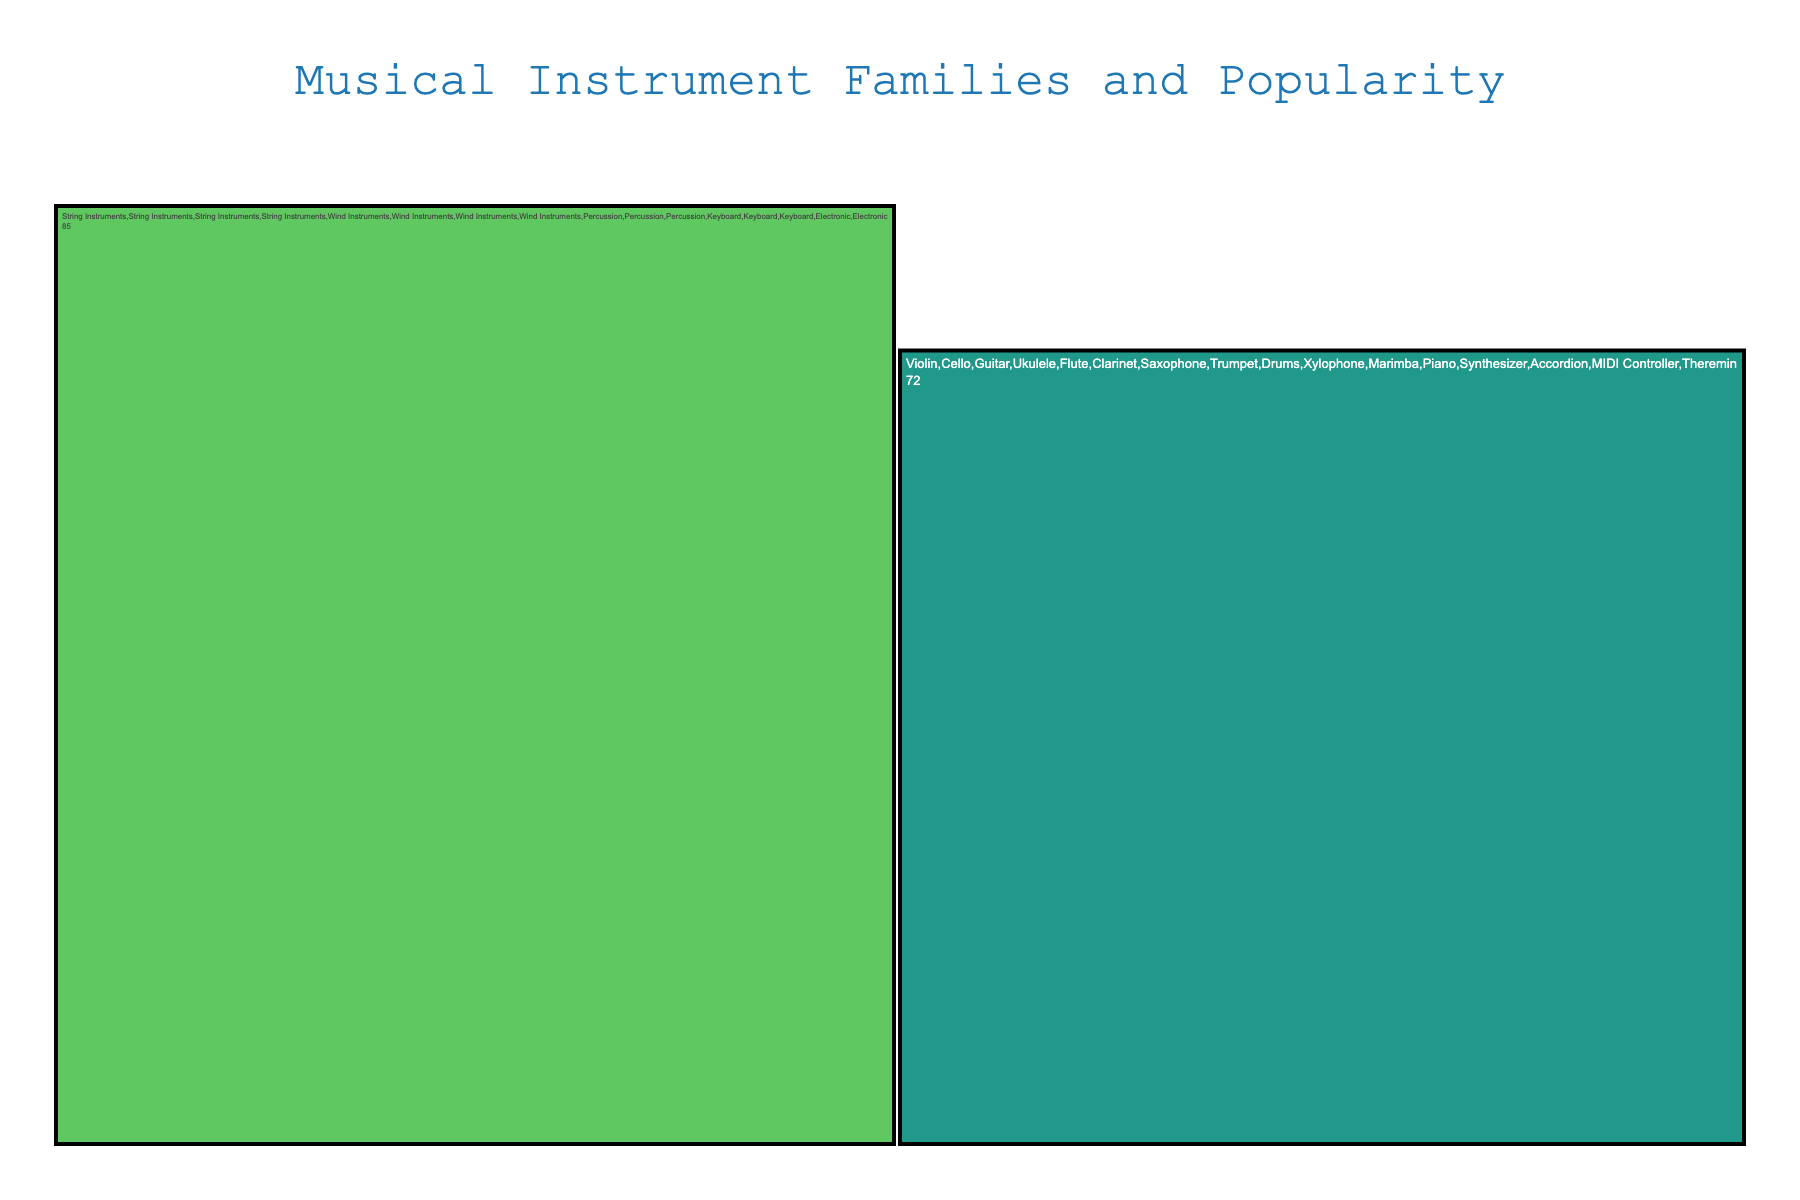What's the title of the figure? The title is typically located at the top of the figure, often centered. By looking there, we can directly read it.
Answer: Musical Instrument Families and Popularity Which subcategory within String Instruments has the highest popularity? By locating the String Instruments branch in the Icicle Chart, we can see and compare the popularity values for each subcategory. The Guitar has 95, higher than Violin, Cello, and Ukulele.
Answer: Guitar How many subcategories are there in the Wind Instruments family? Wind Instruments should have its branches appearing from it. We can count the number of subcategories listed directly under Wind Instruments in the figure.
Answer: 4 What's the combined popularity of the Drums and Piano? We need to find and sum the popularity values of Drums in the Percussion family and Piano in the Keyboard family. Drums have 92, and Piano has 90. Therefore, 92 + 90 = 182.
Answer: 182 Which instrument family has the overall least popular subcategory, and what is it? To find this, we need to look through each family's subcategories for the lowest popularity value, which involves visually scanning all branches. The least popular subcategory is Theremin in the Electronic family with a popularity of 40.
Answer: Electronic, Theremin Is the Accordion more or less popular than the Trumpet? We can compare the popularity values of Accordion under Keyboard Instruments and Trumpet under Wind Instruments. Accordion has 60, while Trumpet has 70. Therefore, Accordion is less popular than Trumpet.
Answer: Less Which family has the highest cumulative popularity among its subcategories? We need to sum the popularity values of all subcategories within each family and compare the totals to find the highest one. Calculations are: String Instruments (85+72+95+78 = 330), Wind Instruments (80+75+88+70 = 313), Percussion (92+65+55 = 212), Keyboard (90+82+60 = 232), Electronic (75+40 = 115). String Instruments have the highest cumulative popularity of 330.
Answer: String Instruments What's the difference in popularity between the Flute and the Saxophone? We identify the respective popularity values under the Wind Instruments family for Flute and Saxophone and subtract them (88 - 80). Thus, 88 - 80 = 8.
Answer: 8 How does the popularity of the Synthesizer compare to that of the Violin? By checking both under their respective families, we compare Synthesizer’s popularity (82) with the Violin’s (85). Synthesizer is less popular than Violin by 3 (85 - 82 = 3).
Answer: Less, by 3 